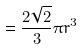<formula> <loc_0><loc_0><loc_500><loc_500>= \frac { 2 \sqrt { 2 } } { 3 } \pi r ^ { 3 }</formula> 